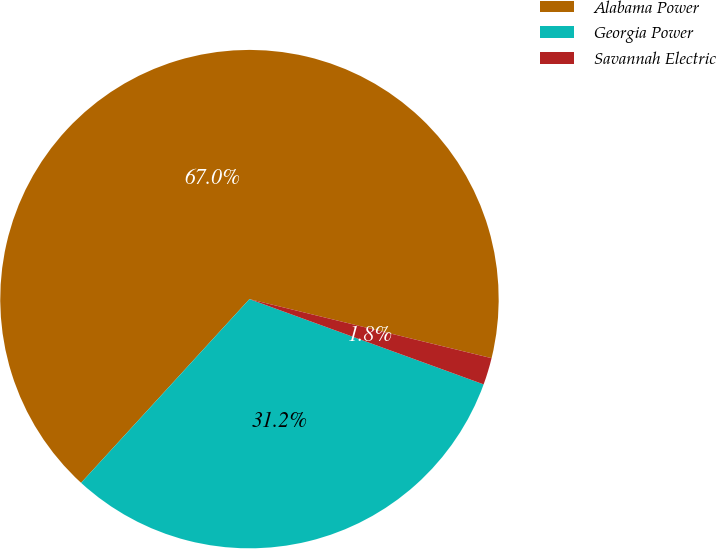Convert chart. <chart><loc_0><loc_0><loc_500><loc_500><pie_chart><fcel>Alabama Power<fcel>Georgia Power<fcel>Savannah Electric<nl><fcel>67.0%<fcel>31.25%<fcel>1.75%<nl></chart> 